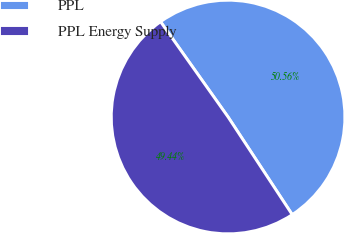Convert chart. <chart><loc_0><loc_0><loc_500><loc_500><pie_chart><fcel>PPL<fcel>PPL Energy Supply<nl><fcel>50.56%<fcel>49.44%<nl></chart> 